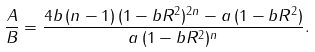<formula> <loc_0><loc_0><loc_500><loc_500>\frac { A } { B } = \frac { 4 b \, ( n - 1 ) \, ( 1 - b R ^ { 2 } ) ^ { 2 n } - a \, ( 1 - b R ^ { 2 } ) } { a \, ( 1 - b R ^ { 2 } ) ^ { n } } .</formula> 